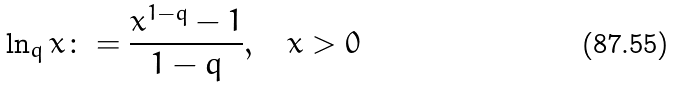<formula> <loc_0><loc_0><loc_500><loc_500>\ln _ { q } x \colon = \frac { x ^ { 1 - q } - 1 } { 1 - q } , \quad x > 0</formula> 